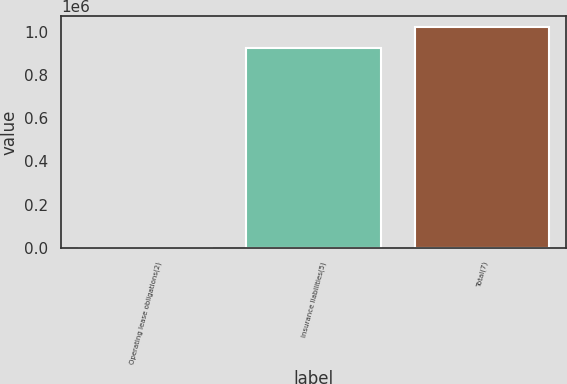<chart> <loc_0><loc_0><loc_500><loc_500><bar_chart><fcel>Operating lease obligations(2)<fcel>Insurance liabilities(5)<fcel>Total(7)<nl><fcel>205<fcel>926540<fcel>1.02066e+06<nl></chart> 